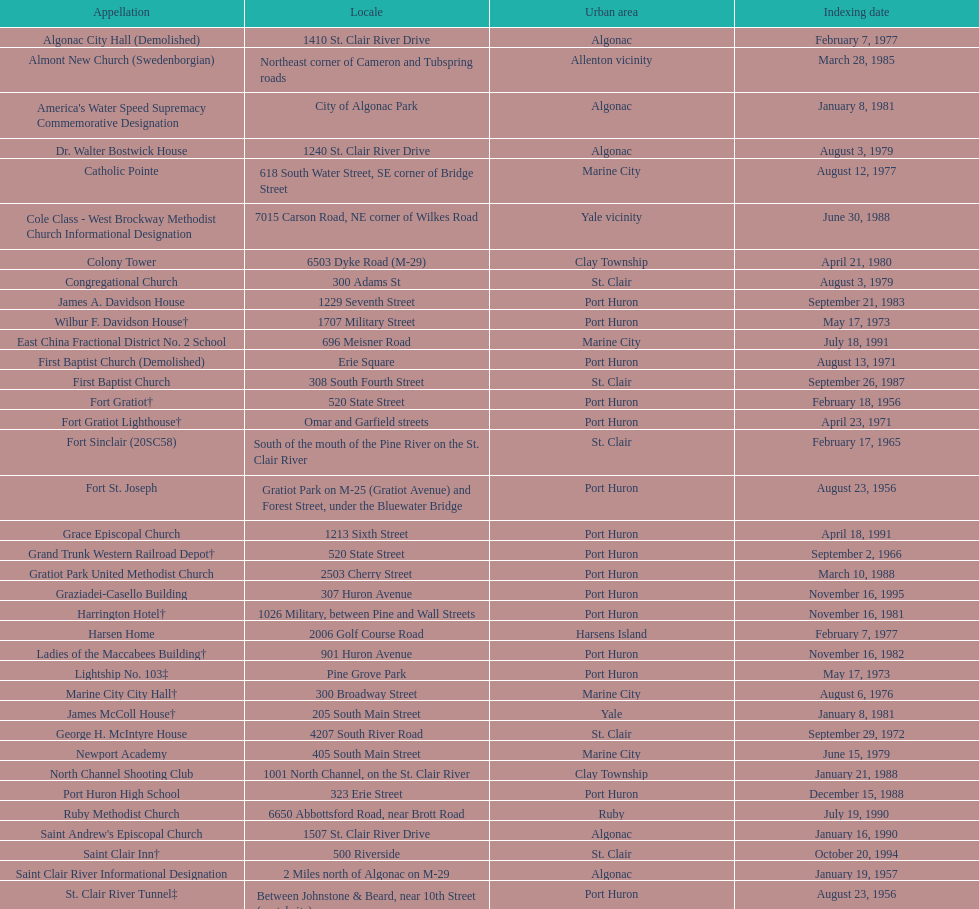Fort gratiot lighthouse and fort st. joseph are located in what city? Port Huron. 